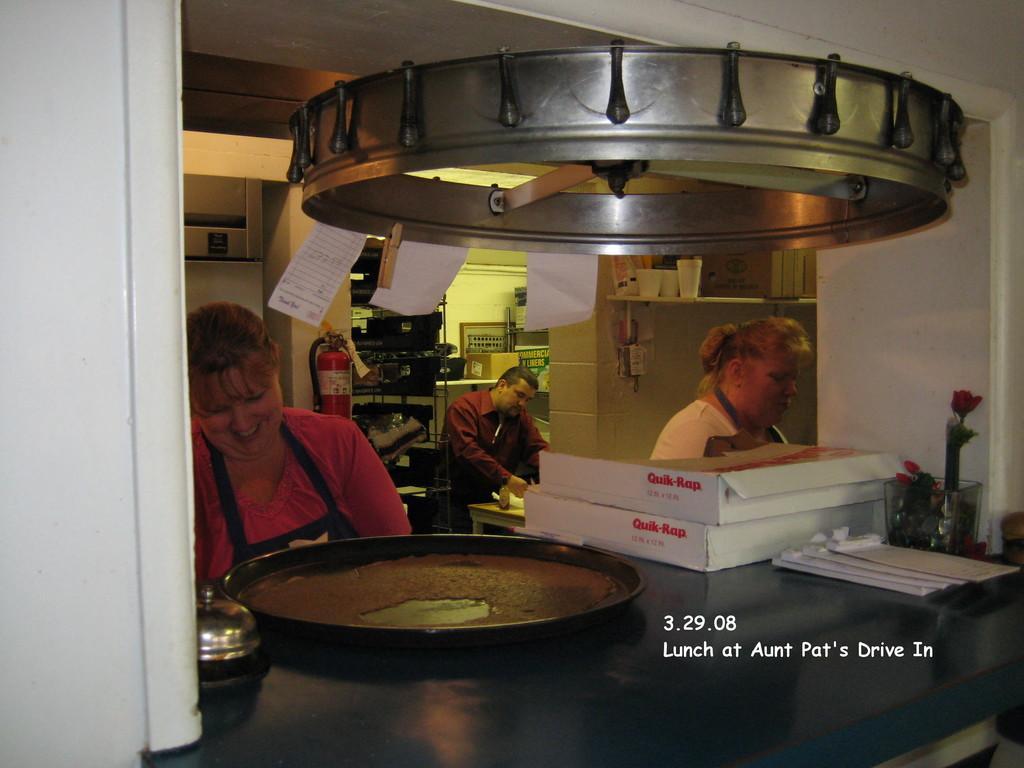Could you give a brief overview of what you see in this image? In this image, I can see a man and two women. In front of the women, I can see a plate, cardboard boxes, flower vase and few other objects on a table. Behind the women, there are objects and I can see a fire extinguisher attached to a wall. At the top of the image, I can see the papers hanging to an object. In the bottom right side of the image, I can see a watermark. 